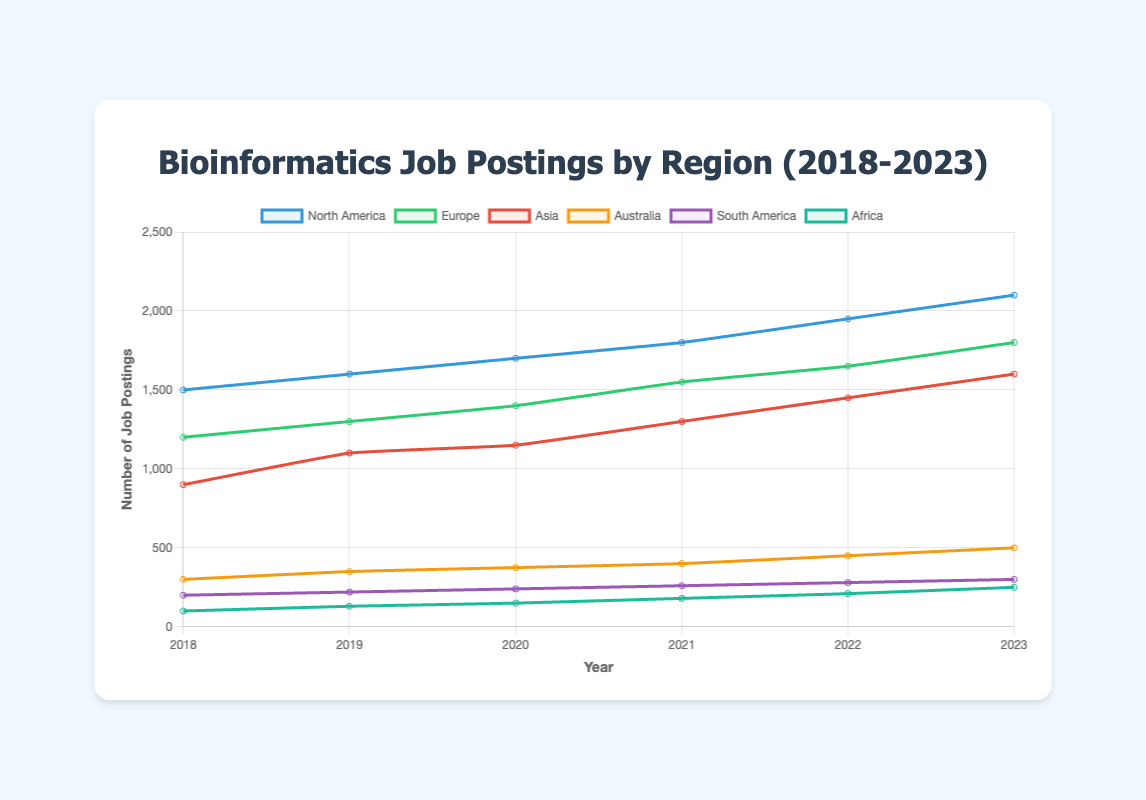What is the total number of bioinformatics job postings in North America over the five-year period? Sum the number of job postings for North America from 2018 to 2023: 1500 + 1600 + 1700 + 1800 + 1950 + 2100 = 10650
Answer: 10650 Which region showed the greatest increase in bioinformatics job postings from 2018 to 2023? Calculate the difference in job postings for each region between 2018 and 2023 and compare. North America: 2100 - 1500 = 600, Europe: 1800 - 1200 = 600, Asia: 1600 - 900 = 700, Australia: 500 - 300 = 200, South America: 300 - 200 = 100, Africa: 250 - 100 = 150. Asia has the greatest increase of 700
Answer: Asia Which region had the least number of bioinformatics job postings in 2023? Compare the numbers for each region in 2023: North America (2100), Europe (1800), Asia (1600), Australia (500), South America (300), Africa (250). Africa has the least with 250
Answer: Africa By how much did the job postings in Europe increase from 2021 to 2023? Subtract the number of job postings in Europe in 2021 from those in 2023: 1800 - 1550 = 250
Answer: 250 In which year did Australia see the smallest number of bioinformatics job postings? Compare the job posting numbers for Australia from 2018 to 2023. Those are: 2018: 300, 2019: 350, 2020: 375, 2021: 400, 2022: 450, 2023: 500. The smallest number was in 2018 with 300
Answer: 2018 How many more job postings were there in North America than in Europe in 2020? Subtract the number of job postings in Europe from those in North America in 2020: 1700 - 1400 = 300
Answer: 300 Which two regions had the closest number of job postings in 2022, and what is the difference between them? Calculate the differences between job postings in each region in 2022 and find the closest pair: North America (1950), Europe (1650), Asia (1450), Australia (450), South America (280), Africa (210). Differences: North America vs Europe: 300, Europe vs Asia: 200, Asia vs Australia: 1000, Australia vs South America: 170, South America vs Africa: 70. The closest pair is South America and Africa with a difference of 70
Answer: South America and Africa; 70 What is the average number of bioinformatics job postings in Asia over the given period? Sum the job postings in Asia from 2018 to 2023 and then divide by 6: (900 + 1100 + 1150 + 1300 + 1450 + 1600) / 6 = 12166.67
Answer: 1250 In which year did South America see the largest increase in job postings over the previous year, and what was the increase? Compare the year-by-year increases: 2019 (220-200 = 20), 2020 (240-220 = 20), 2021 (260-240 = 20), 2022 (280-260=20), 2023 (300-280=20). The largest increase of 20 happened in every year
Answer: 2019, 20 Which regions had more than 1000 job postings in 2023? Identify regions with postings greater than 1000 in 2023: North America (2100), Europe (1800), Asia (1600). These regions had more than 1000
Answer: North America, Europe, Asia 